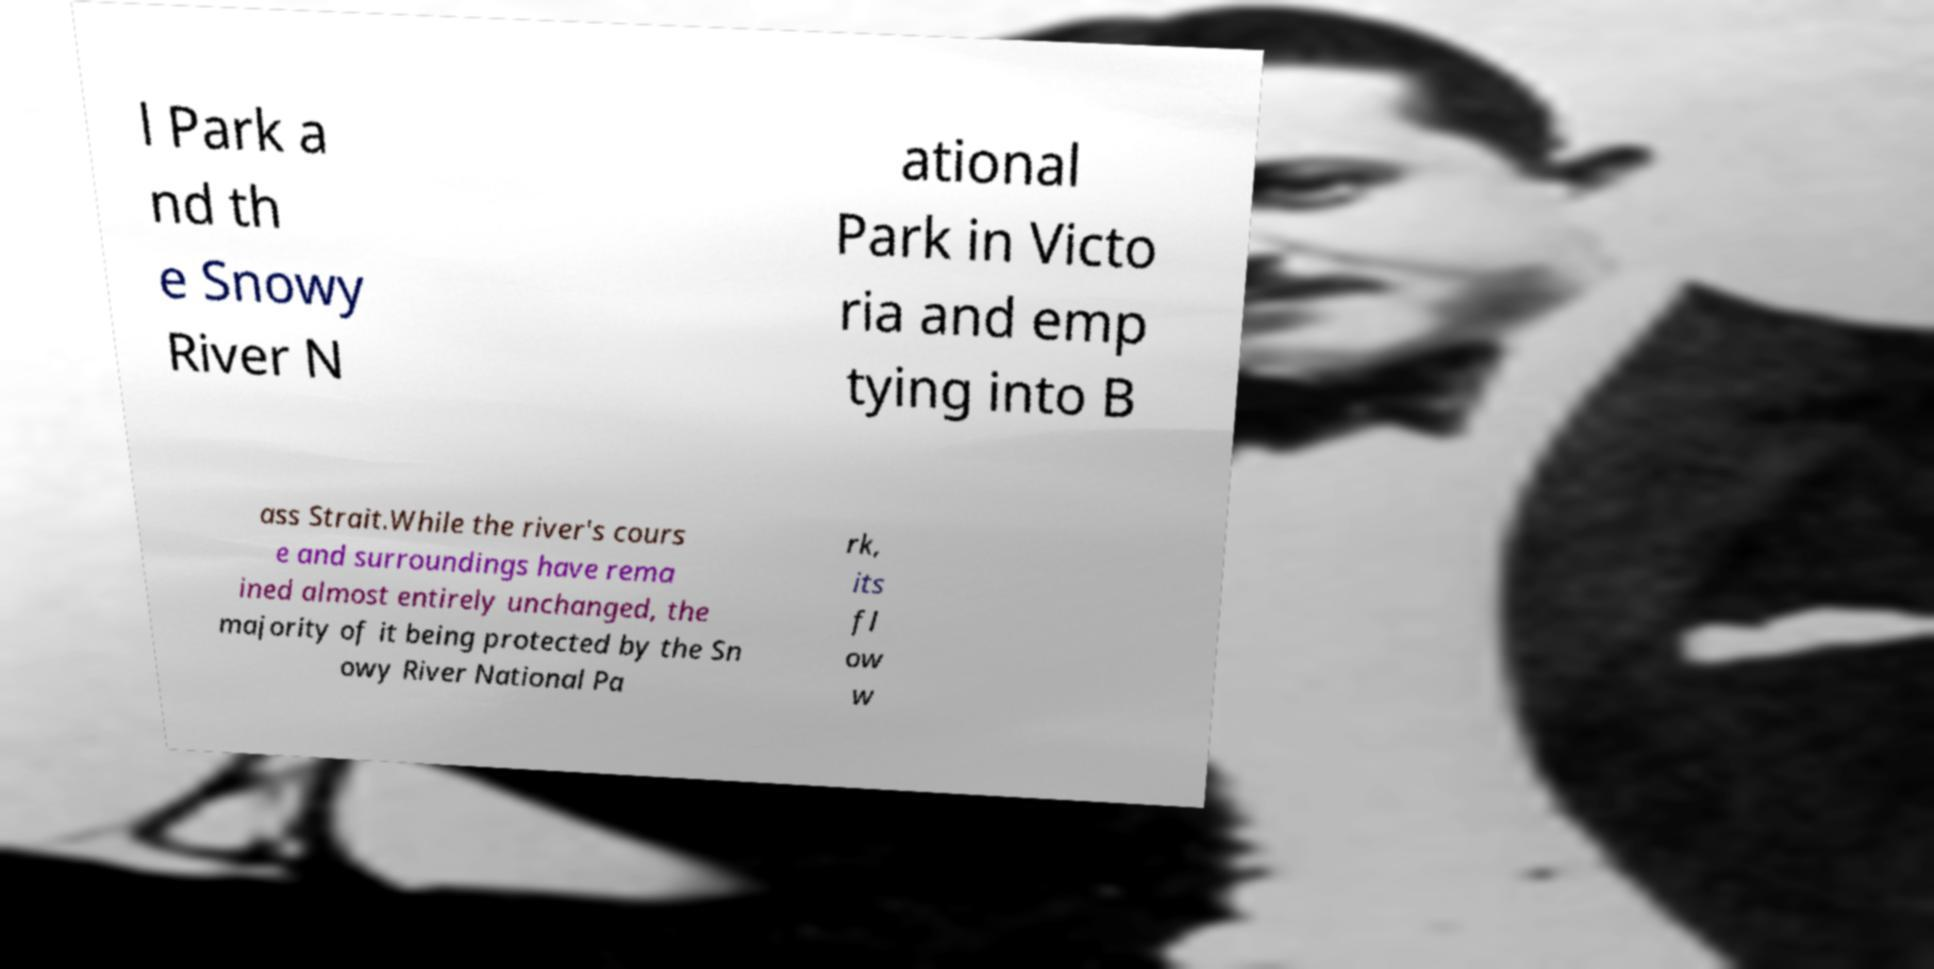Please identify and transcribe the text found in this image. l Park a nd th e Snowy River N ational Park in Victo ria and emp tying into B ass Strait.While the river's cours e and surroundings have rema ined almost entirely unchanged, the majority of it being protected by the Sn owy River National Pa rk, its fl ow w 